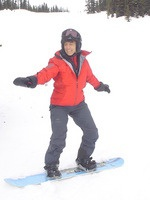Describe the objects in this image and their specific colors. I can see people in gray, salmon, and darkgray tones and snowboard in gray, lightgray, lightblue, and darkgray tones in this image. 